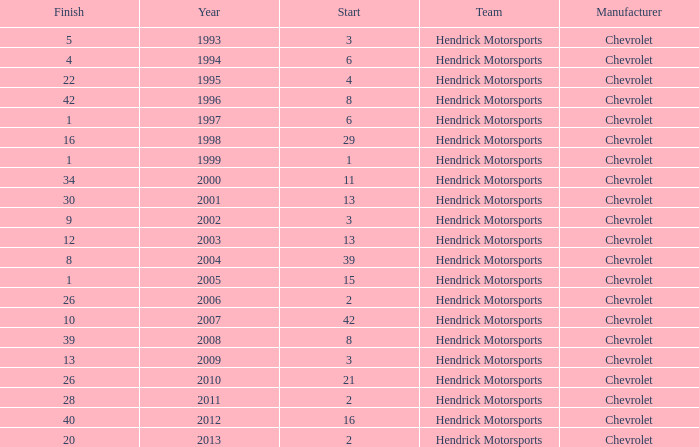What was Jeff's finish in 2011? 28.0. 